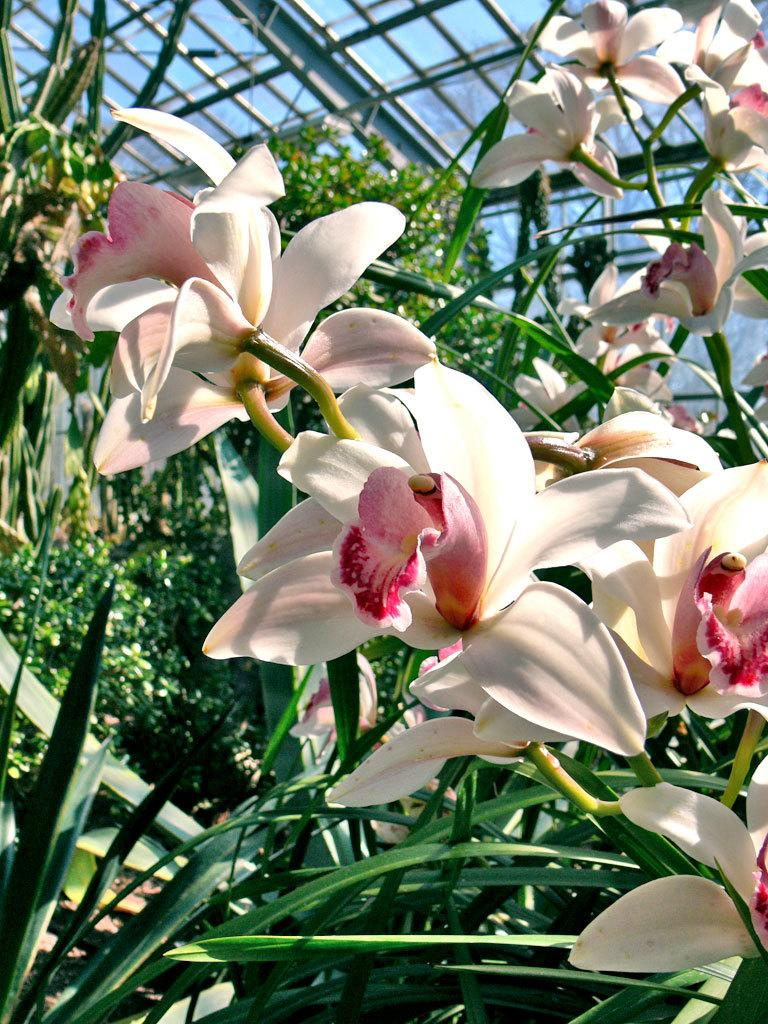What type of living organisms can be seen in the image? Plants and flowers are visible in the image. Can you describe the flowers in the image? There are flowers in the image, but their specific characteristics are not mentioned in the provided facts. What is visible at the top of the image? A: There is a roof visible at the top of the image. How many hands are holding the flowers in the image? There are no hands visible in the image, as it only features plants, flowers, and a roof. What type of net is used to catch the falling petals in the image? There is no net or falling petals present in the image. 